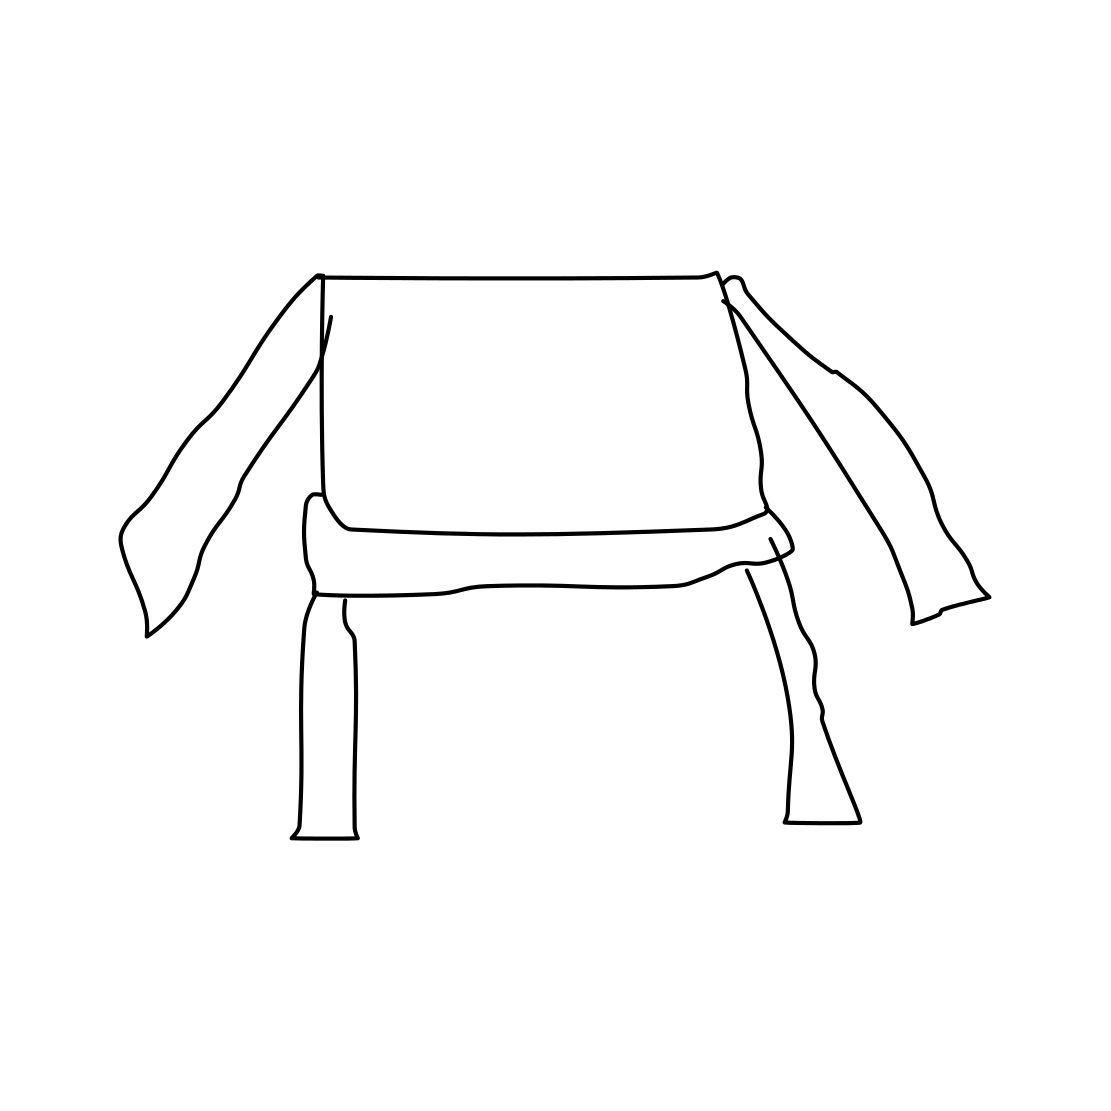Is there any functionality implied in this design? The design seems to imply a functional aspect, presumably that of a chair. The four extended lines suggest legs for support, and the horizontal shaded area could be interpreted as a seat, while the two protruding lines on either side could be armrests or decorative elements. 